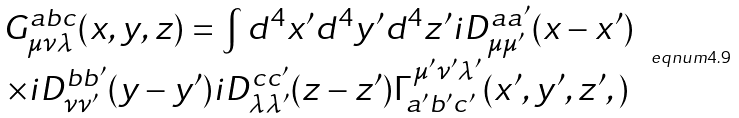<formula> <loc_0><loc_0><loc_500><loc_500>\begin{array} { c } G _ { \mu \nu \lambda } ^ { a b c } ( x , y , z ) = \int d ^ { 4 } x ^ { \prime } d ^ { 4 } y ^ { \prime } d ^ { 4 } z ^ { \prime } i D _ { \mu \mu ^ { \prime } } ^ { a a ^ { \prime } } ( x - x ^ { \prime } ) \\ \times i D _ { \nu \nu ^ { \prime } } ^ { b b ^ { \prime } } ( y - y ^ { \prime } ) i D _ { \lambda \lambda ^ { \prime } } ^ { c c ^ { \prime } } ( z - z ^ { \prime } ) \Gamma _ { a ^ { \prime } b ^ { \prime } c ^ { \prime } } ^ { \mu ^ { \prime } \nu ^ { \prime } \lambda ^ { \prime } } ( x ^ { \prime } , y ^ { \prime } , z ^ { \prime } , ) \end{array} \ e q n u m { 4 . 9 }</formula> 